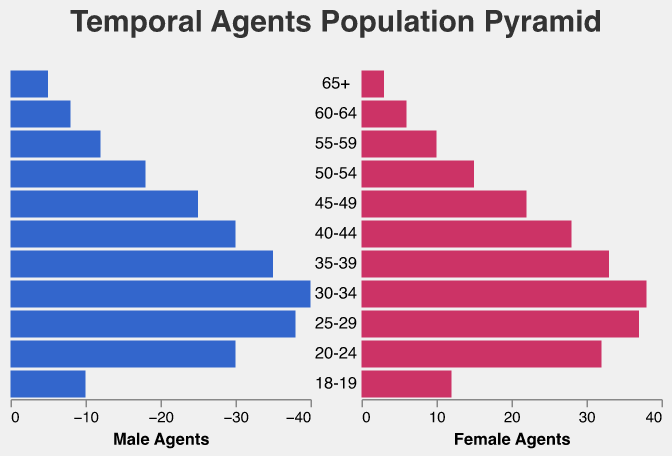What is the title of the figure? The title of the figure is generally at the top of the chart and is in a larger font compared to the other elements. The provided code shows the title being "Temporal Agents Population Pyramid".
Answer: Temporal Agents Population Pyramid Which age group has the highest number of Male Agents? To find the age group with the highest number of Male Agents, you look for the age group with the longest bar in the Male Agents section. In the data, the "30-34" age group has the highest number of Male Agents with 40 agents.
Answer: 30-34 Compare the number of Female Agents in the "20-24" and "25-29" age groups. Which group has more Female Agents? The "20-24" age group has 32 Female Agents and the "25-29" age group has 37 Female Agents. By comparing these two numbers, it is clear that the "25-29" age group has more Female Agents.
Answer: 25-29 How many more Male Agents are there in the "45-49" age group compared to the "60-64" age group? The "45-49" age group has 25 Male Agents and the "60-64" age group has 8 Male Agents. The difference is calculated by subtracting the number of Male Agents in the "60-64" age group from the number in the "45-49" age group: 25 - 8 = 17.
Answer: 17 What is the total number of Female Agents in the "55-59" and "65+" age groups combined? To find the total number, add the number of Female Agents in the "55-59" age group (10) to those in the "65+" age group (3): 10 + 3 = 13.
Answer: 13 Which age group has a greater number of agents when combining both Male and Female Agents, "30-34" or "25-29"? For "30-34", the combined total is 40 Male Agents + 38 Female Agents = 78. For "25-29", the combined total is 38 Male Agents + 37 Female Agents = 75. The "30-34" age group has more combined agents.
Answer: 30-34 What is the age group with the smallest gender ratio difference in favor of Female Agents? The gender ratio difference can be calculated by subtracting the number of Male Agents from Female Agents for each age group. The "20-24" age group has 32 Female Agents and 30 Male Agents, resulting in a difference of 2, which is the smallest difference where Female Agents are more than Male Agents.
Answer: 20-24 In which age group do the Male Agents significantly outnumber the Female Agents? Compare the number of Male and Female Agents across all age groups. The age group "65+" has 5 Male Agents and 3 Female Agents. Here, Male Agents outnumber Female Agents by 2, but it's not significant. The "40-44" age group has 30 Male Agents and 28 Female Agents, again not significant. The "55-59" age group with 12 Male Agents and 10 Female Agents also shows a small difference. The "45-49" age group has 25 Male Agents and 22 Female Agents which is a difference of 3. In all these cases, the "45-49" age group has the highest outnumbering, but it's still not extremely significant. For a significant difference, a higher number such as "30-34" with 40 Male Agents and 38 Female Agents can be concluded to a close difference but "45-49" holds a more apparent overall significant number by age comparison.
Answer: 45-49 